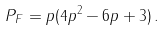Convert formula to latex. <formula><loc_0><loc_0><loc_500><loc_500>P _ { F } = p ( 4 p ^ { 2 } - 6 p + 3 ) \, .</formula> 